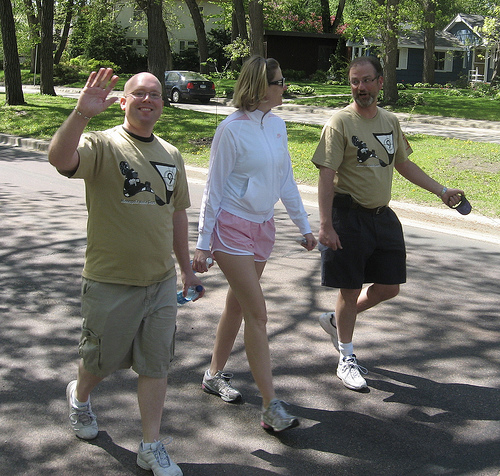<image>
Can you confirm if the tree is in front of the woman? No. The tree is not in front of the woman. The spatial positioning shows a different relationship between these objects. 